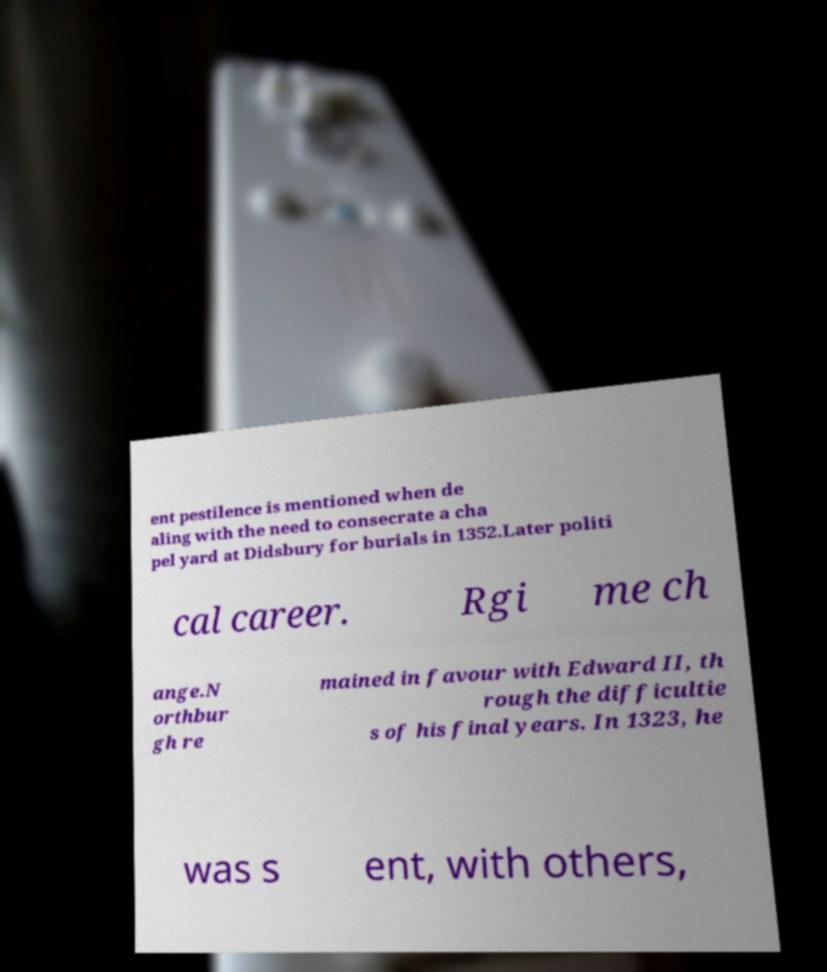What messages or text are displayed in this image? I need them in a readable, typed format. ent pestilence is mentioned when de aling with the need to consecrate a cha pel yard at Didsbury for burials in 1352.Later politi cal career. Rgi me ch ange.N orthbur gh re mained in favour with Edward II, th rough the difficultie s of his final years. In 1323, he was s ent, with others, 